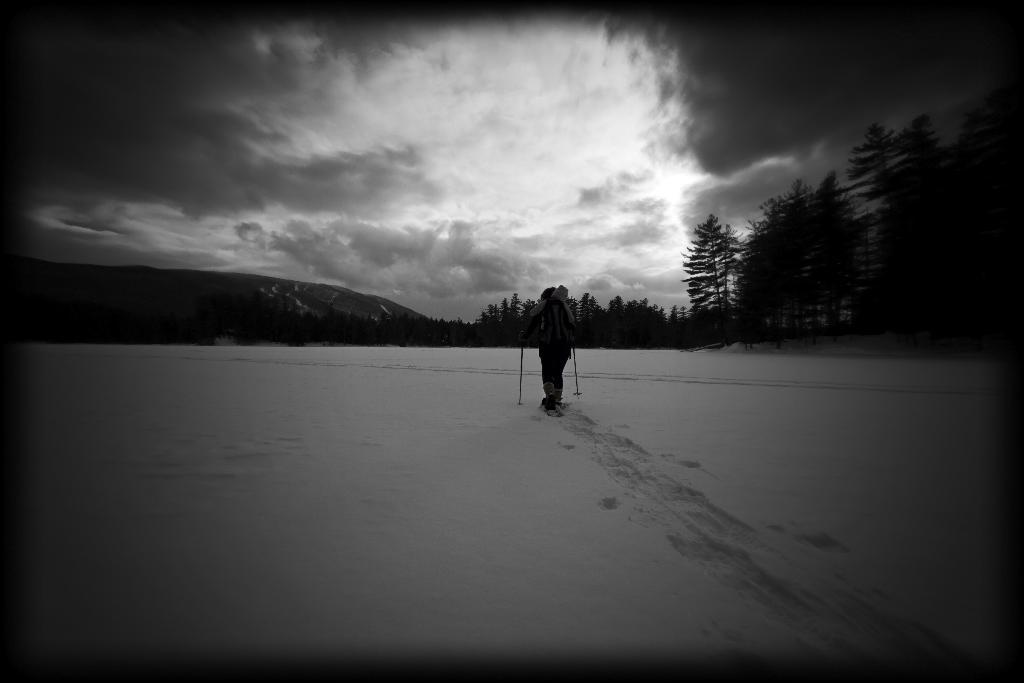What is the person in the image doing? The person is skating on snow. What is the person holding in his hands? The person is holding sticks in his hands. What can be seen in the background of the image? There is a group of trees and a cloudy sky in the background of the image. What type of leaf is the person holding in his hand? There is no leaf present in the image; the person is holding sticks, which are likely hockey sticks. 